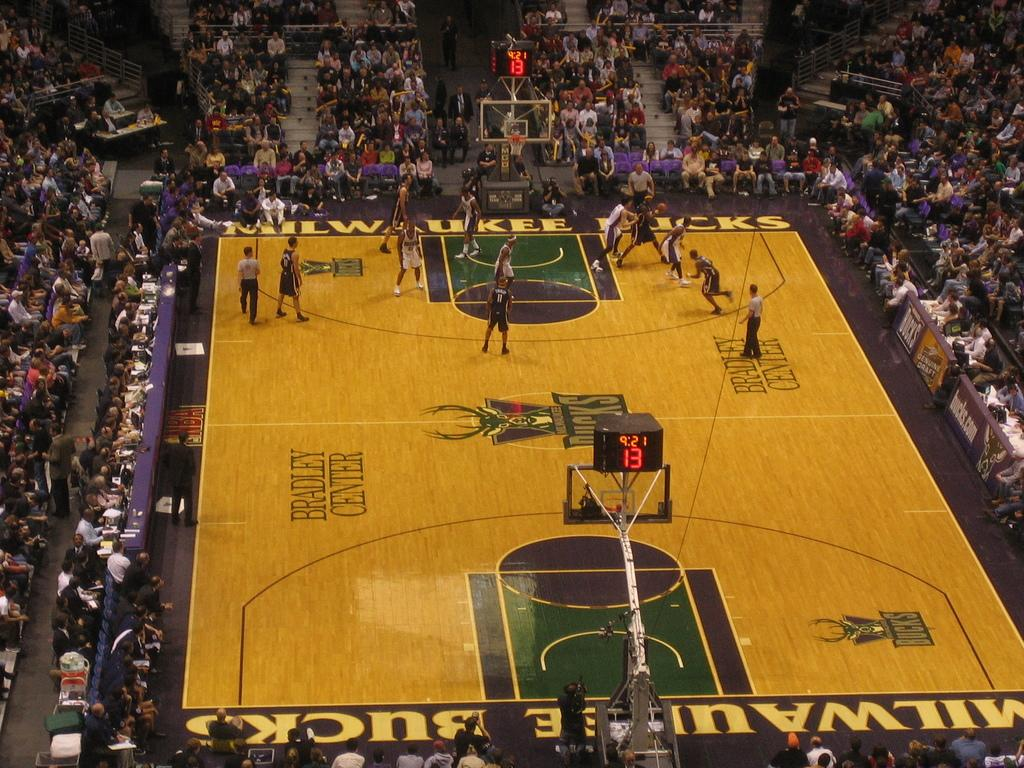What is the main subject of the picture? The main subject of the picture is a playground. Who is present at the playground? There are people inside the playground, and audience members are sitting around it. What can be used to keep track of scores or results? There is a scoreboard in the image. What type of copy is being made by the playground equipment in the image? There is no copy being made by the playground equipment in the image, as it is not a device capable of making copies. 